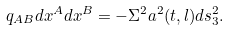<formula> <loc_0><loc_0><loc_500><loc_500>q _ { A B } d x ^ { A } d x ^ { B } = - \Sigma ^ { 2 } a ^ { 2 } ( t , l ) d s _ { 3 } ^ { 2 } .</formula> 